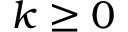<formula> <loc_0><loc_0><loc_500><loc_500>k \geq 0</formula> 